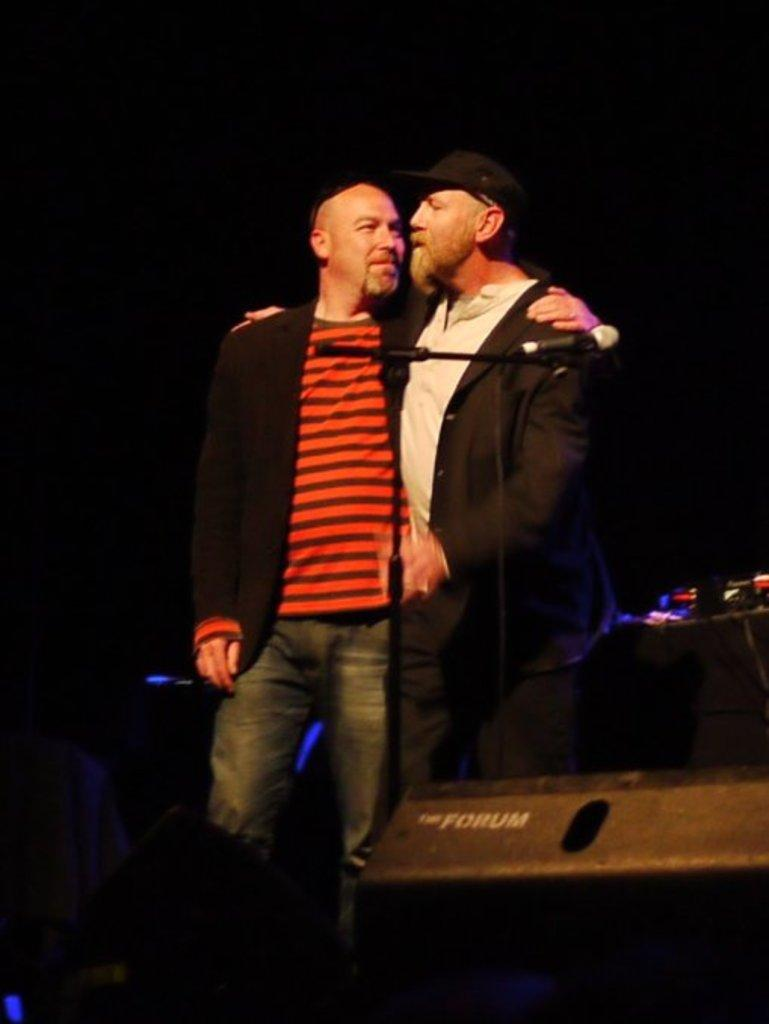How many people are in the image? There are two men in the image. What object is present in the image that is commonly used for amplifying sound? There is a microphone in the image. What can be observed about the lighting in the image? The background of the image is dark. What type of berry can be seen growing on the microphone in the image? There are no berries present in the image, and the microphone is not a plant or a location where berries would grow. 